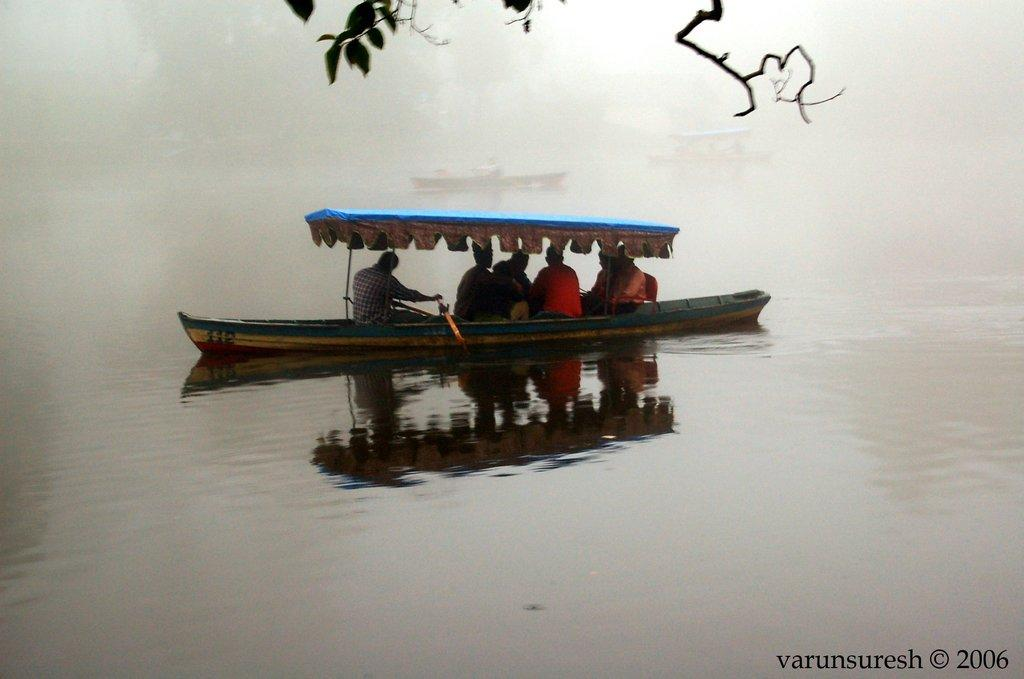What are the people in the image doing? The people in the image are sitting in a boat. Where is the boat located? The boat is on the surface of water. What can be seen at the top of the image? Branches and leaves are visible at the top of the image. What type of territory is being claimed by the people in the image? There is no indication in the image that the people are claiming any territory. How many eggs can be seen in the image? There are no eggs present in the image. 